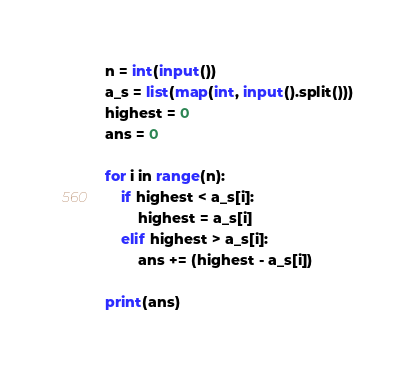<code> <loc_0><loc_0><loc_500><loc_500><_Python_>n = int(input())
a_s = list(map(int, input().split()))
highest = 0
ans = 0

for i in range(n):
    if highest < a_s[i]:
        highest = a_s[i]
    elif highest > a_s[i]:
        ans += (highest - a_s[i])

print(ans)
</code> 